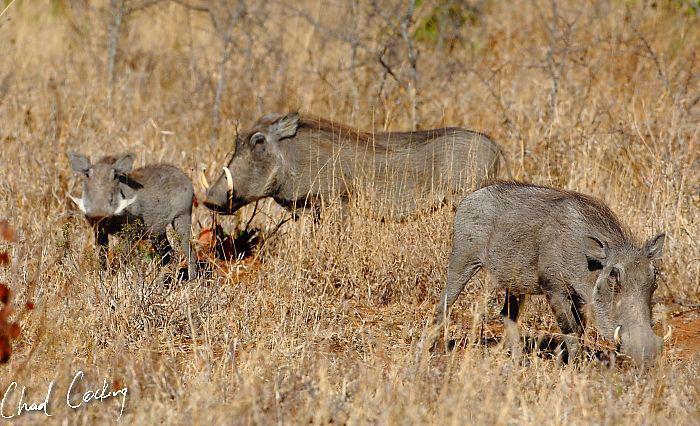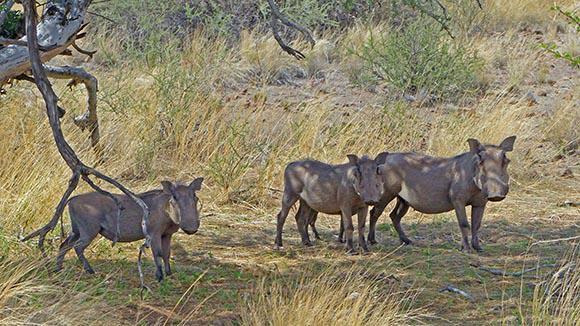The first image is the image on the left, the second image is the image on the right. Given the left and right images, does the statement "there are exactly three boars in the image on the left" hold true? Answer yes or no. Yes. 